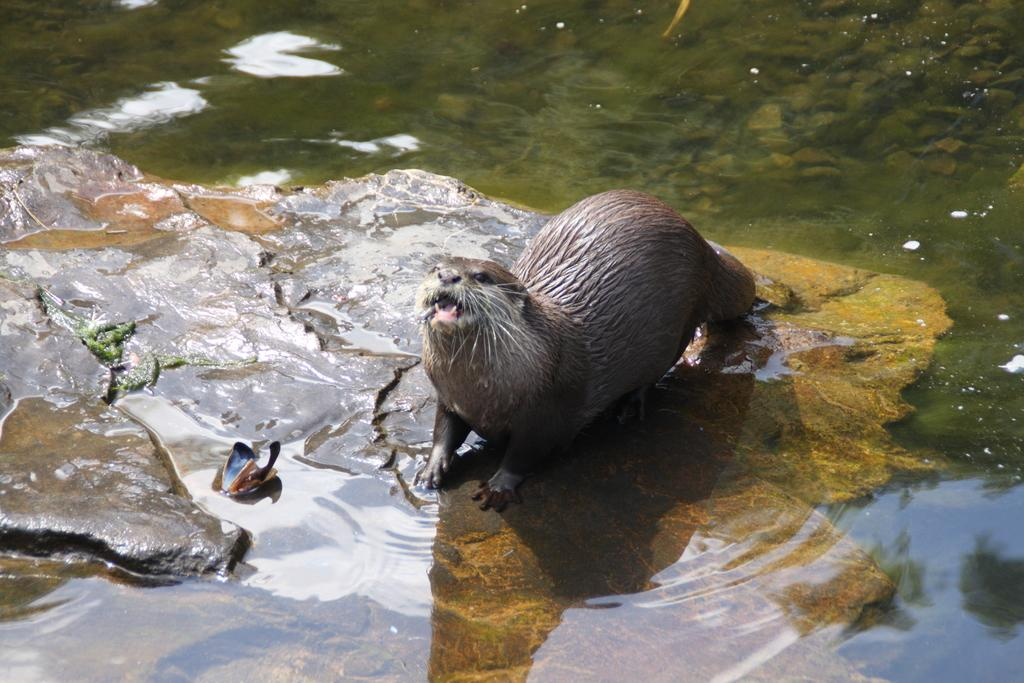What animal is the main subject of the picture? There is a seal in the picture. Where is the seal located? The seal is on a rock. What is the surrounding environment like in the picture? There is a lot of water around the seal and the rock. What type of jail can be seen in the picture? There is no jail present in the picture; it features a seal on a rock surrounded by water. How many people are participating in the mass in the picture? There is no mass or people present in the picture; it features a seal on a rock surrounded by water. 